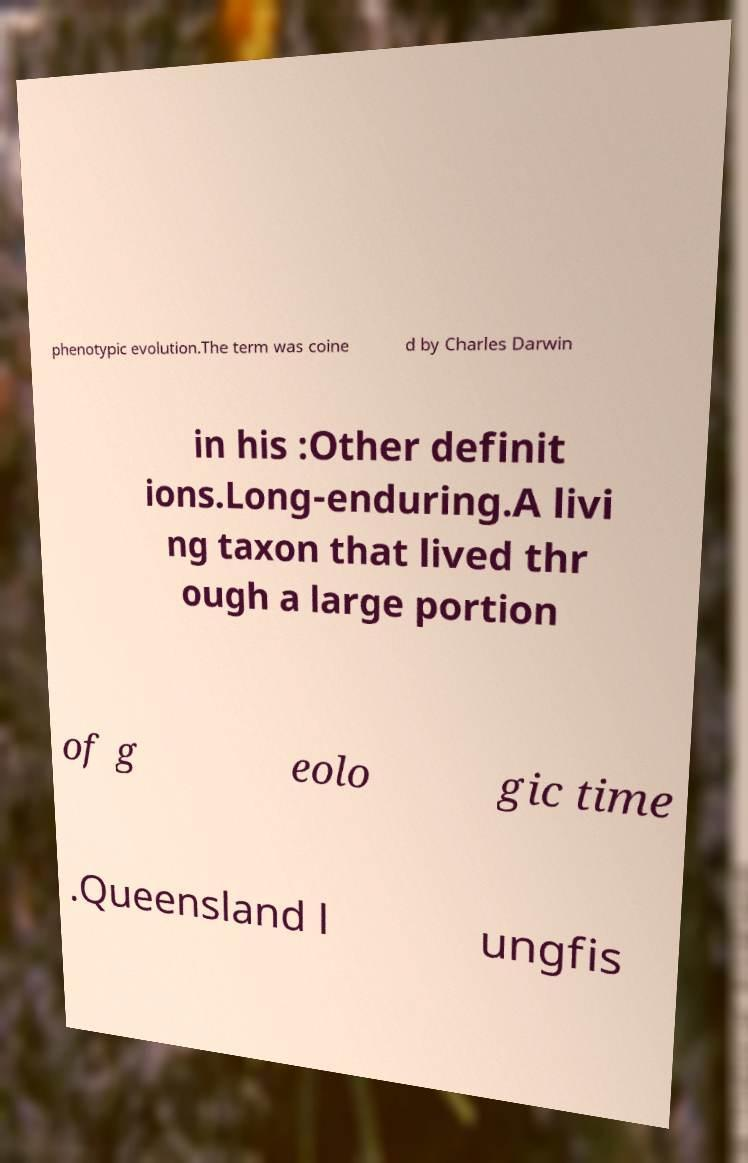Could you assist in decoding the text presented in this image and type it out clearly? phenotypic evolution.The term was coine d by Charles Darwin in his :Other definit ions.Long-enduring.A livi ng taxon that lived thr ough a large portion of g eolo gic time .Queensland l ungfis 